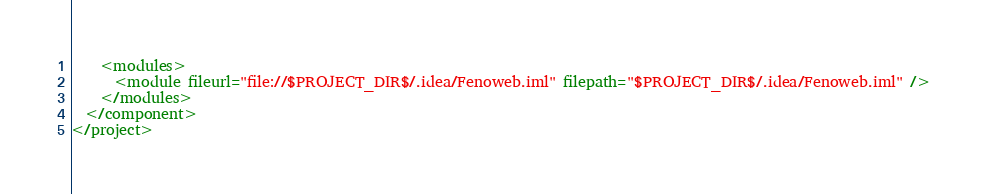Convert code to text. <code><loc_0><loc_0><loc_500><loc_500><_XML_>    <modules>
      <module fileurl="file://$PROJECT_DIR$/.idea/Fenoweb.iml" filepath="$PROJECT_DIR$/.idea/Fenoweb.iml" />
    </modules>
  </component>
</project></code> 